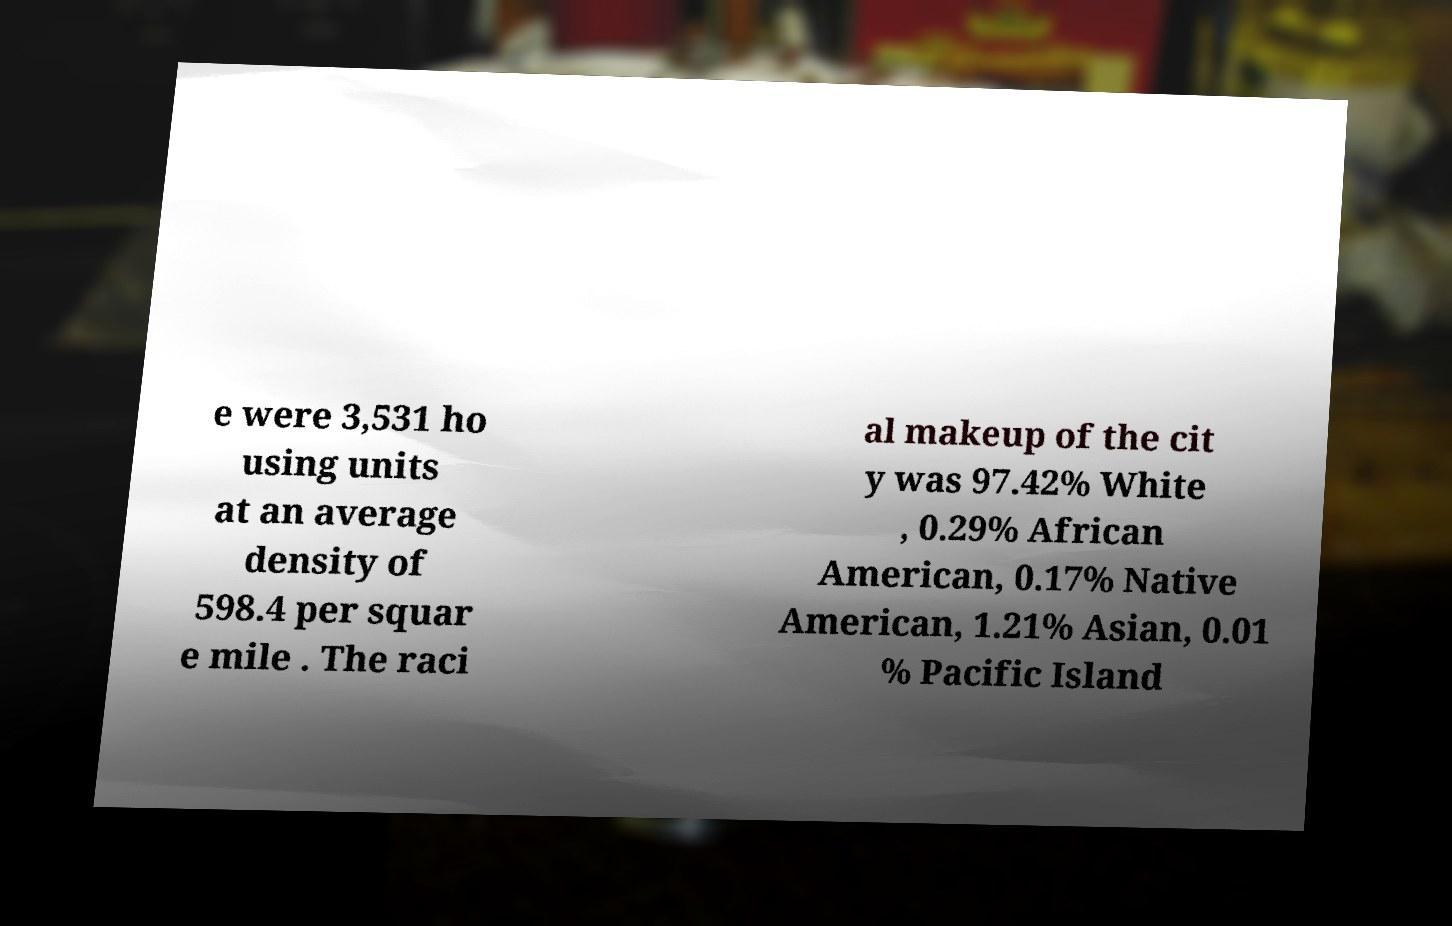Could you assist in decoding the text presented in this image and type it out clearly? e were 3,531 ho using units at an average density of 598.4 per squar e mile . The raci al makeup of the cit y was 97.42% White , 0.29% African American, 0.17% Native American, 1.21% Asian, 0.01 % Pacific Island 